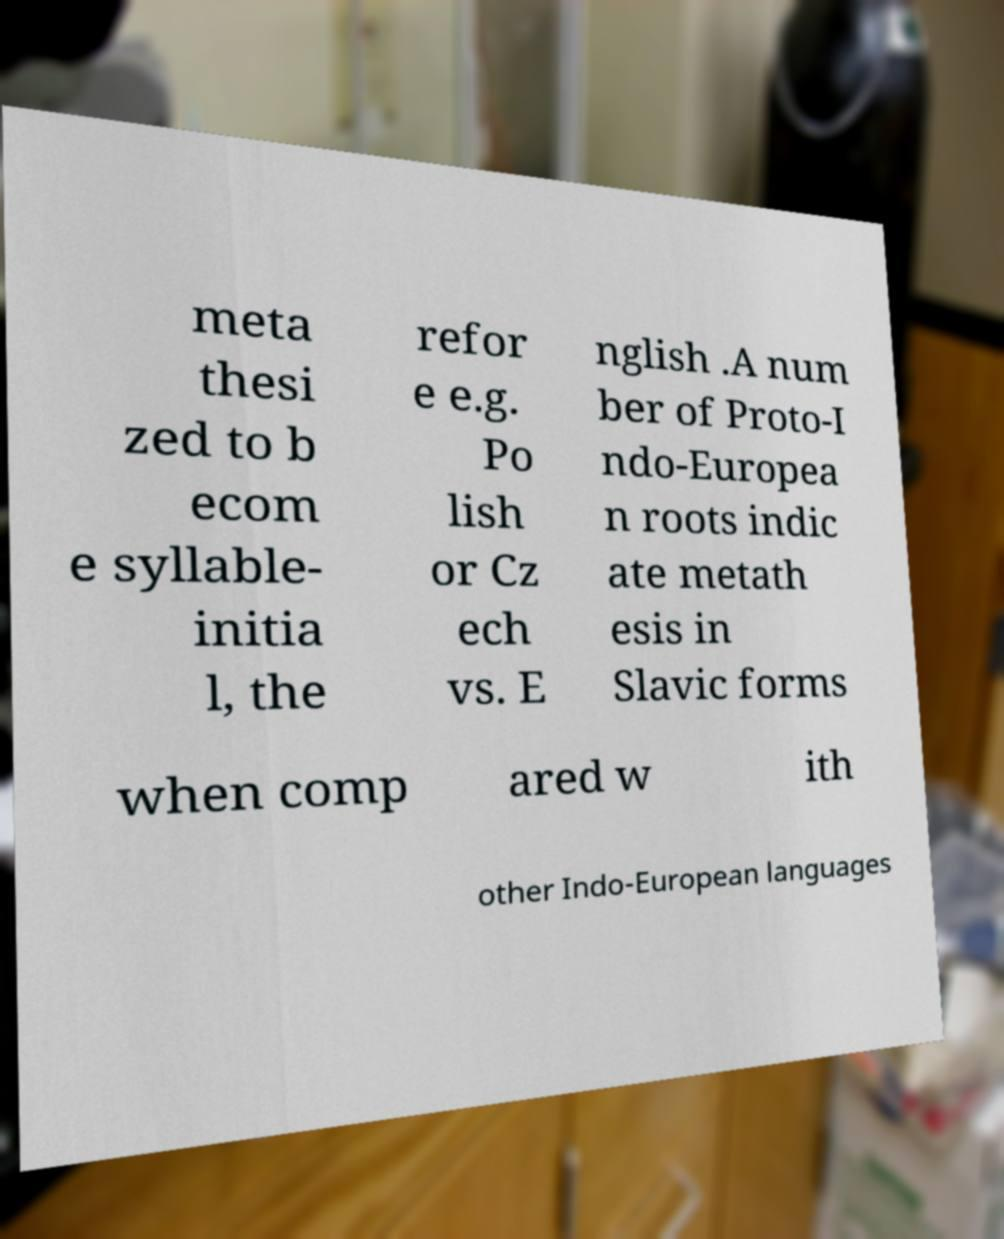There's text embedded in this image that I need extracted. Can you transcribe it verbatim? meta thesi zed to b ecom e syllable- initia l, the refor e e.g. Po lish or Cz ech vs. E nglish .A num ber of Proto-I ndo-Europea n roots indic ate metath esis in Slavic forms when comp ared w ith other Indo-European languages 